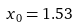Convert formula to latex. <formula><loc_0><loc_0><loc_500><loc_500>x _ { 0 } = 1 . 5 3</formula> 